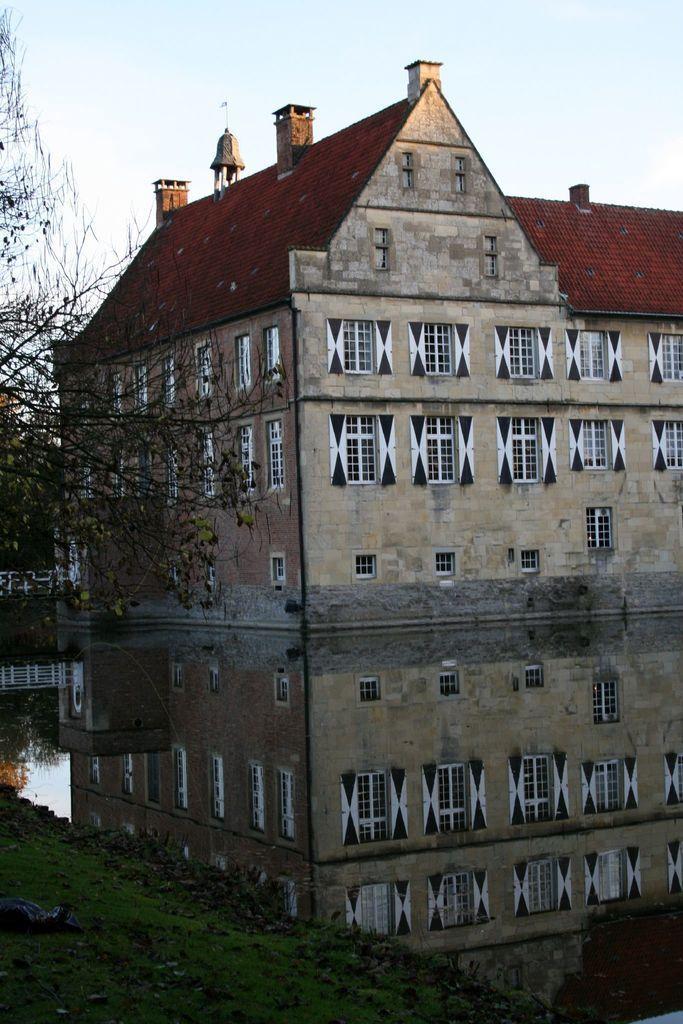How would you summarize this image in a sentence or two? In this picture we can see grass at the bottom, on the left side there is a tree, we can see a building and water in the middle, there is the sky at the top of the picture. 